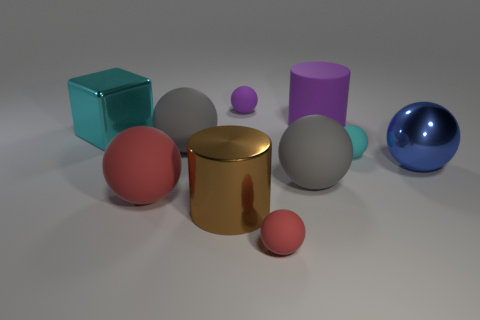Is there a red object of the same size as the blue metallic ball?
Make the answer very short. Yes. There is a ball that is on the right side of the cyan rubber thing; is there a tiny purple rubber thing on the right side of it?
Your answer should be compact. No. What number of cubes are either big purple things or big matte things?
Provide a short and direct response. 0. Is there a big red thing that has the same shape as the blue thing?
Provide a succinct answer. Yes. What is the shape of the tiny purple object?
Ensure brevity in your answer.  Sphere. What number of things are either cyan metal cubes or big brown blocks?
Offer a terse response. 1. Do the sphere behind the large cyan cube and the metallic object that is to the right of the tiny cyan matte thing have the same size?
Provide a short and direct response. No. How many other things are the same material as the small cyan ball?
Your answer should be compact. 6. Is the number of cyan objects that are left of the cyan metallic block greater than the number of cyan rubber balls that are to the right of the tiny cyan thing?
Offer a terse response. No. There is a cyan object in front of the shiny cube; what is its material?
Your answer should be very brief. Rubber. 